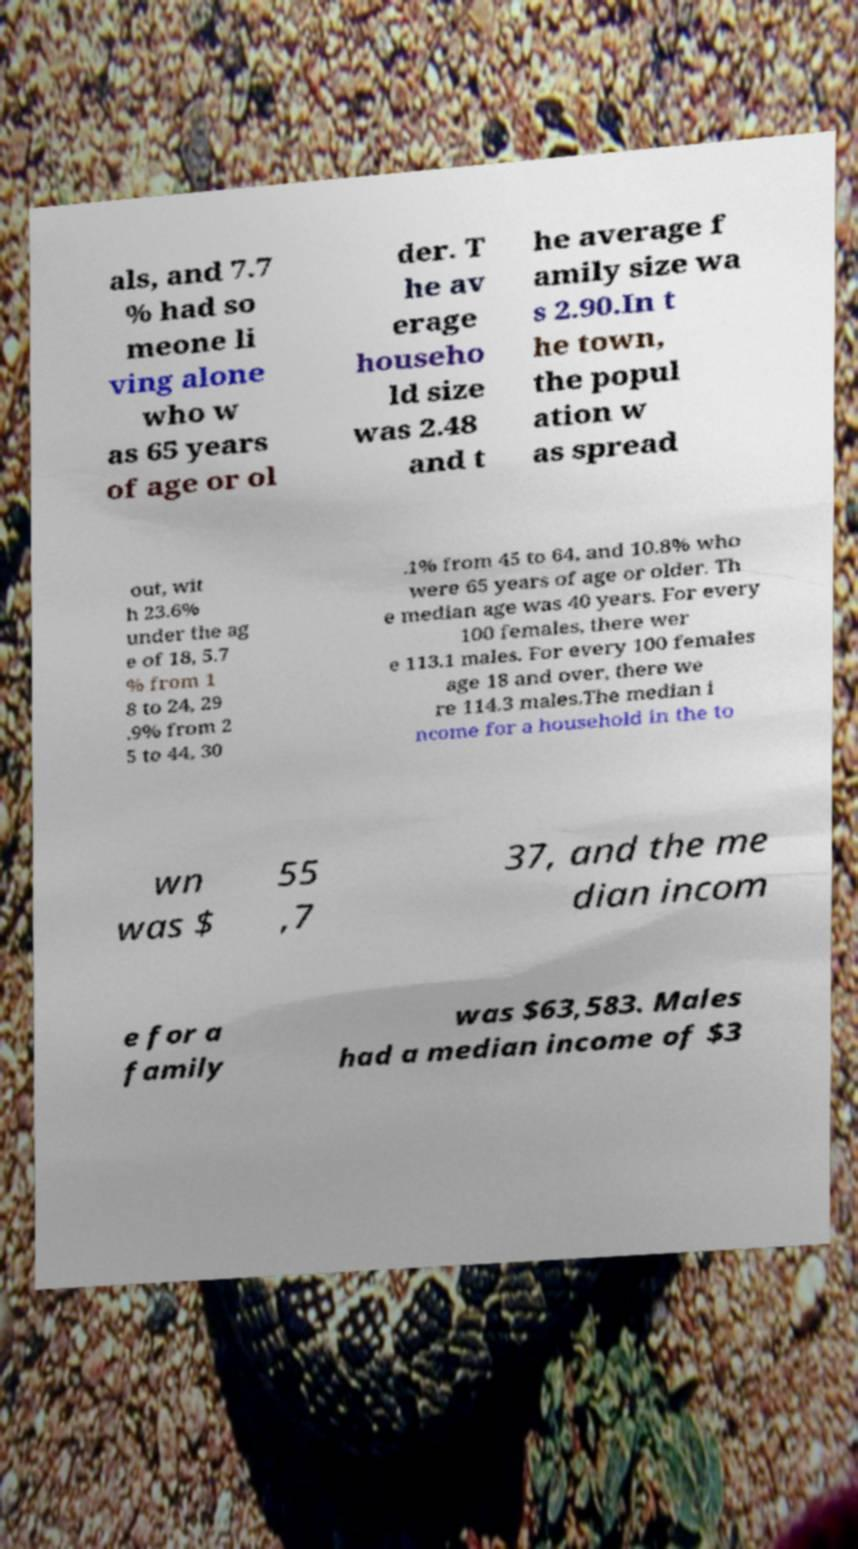Could you assist in decoding the text presented in this image and type it out clearly? als, and 7.7 % had so meone li ving alone who w as 65 years of age or ol der. T he av erage househo ld size was 2.48 and t he average f amily size wa s 2.90.In t he town, the popul ation w as spread out, wit h 23.6% under the ag e of 18, 5.7 % from 1 8 to 24, 29 .9% from 2 5 to 44, 30 .1% from 45 to 64, and 10.8% who were 65 years of age or older. Th e median age was 40 years. For every 100 females, there wer e 113.1 males. For every 100 females age 18 and over, there we re 114.3 males.The median i ncome for a household in the to wn was $ 55 ,7 37, and the me dian incom e for a family was $63,583. Males had a median income of $3 